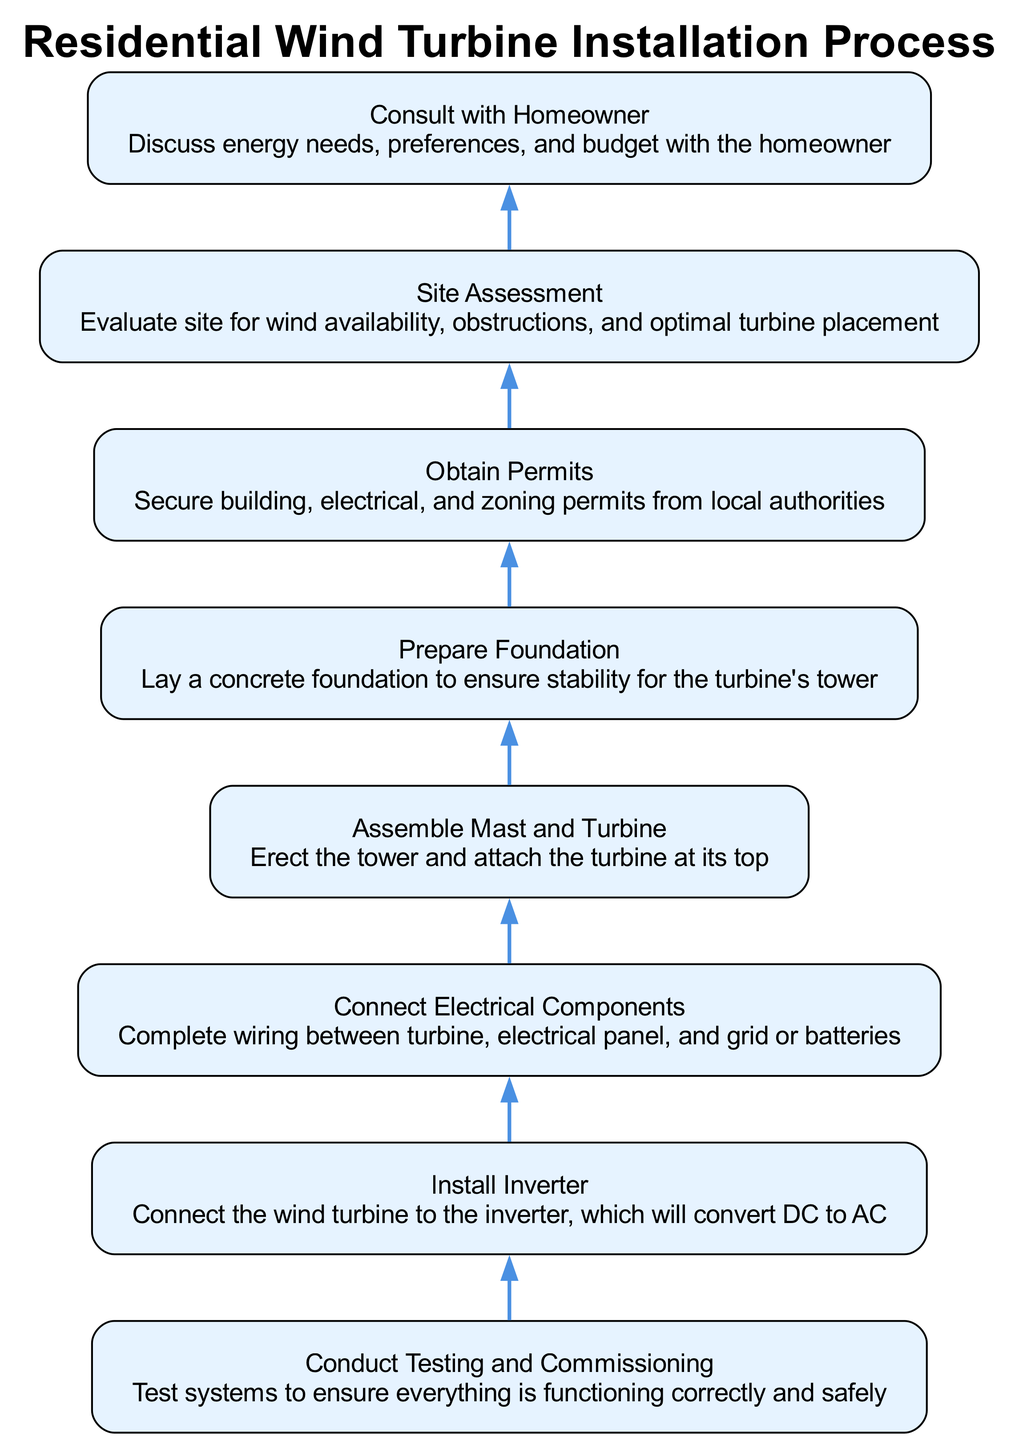What is the first step in the diagram? The first step, which is at the bottom of the flowchart, is "Consult with Homeowner". This is determined by starting from the bottom node and checking which step appears first.
Answer: Consult with Homeowner How many steps are in the installation process? By counting the nodes in the diagram, there are a total of eight distinct steps. Each step is represented by a node in the flowchart.
Answer: Eight What step immediately precedes "Conduct Testing and Commissioning"? The step that comes directly before "Conduct Testing and Commissioning" is "Install Inverter". This can be identified by tracing the flow from the bottom up and looking for the edge connecting to "Conduct Testing and Commissioning".
Answer: Install Inverter What is the purpose of the "Site Assessment" step? The purpose of the "Site Assessment" step is to evaluate site for wind availability, obstructions, and optimal turbine placement, as described in the details of that step in the diagram.
Answer: Evaluate site for wind availability Which step involves laying a concrete foundation? The step that involves laying a concrete foundation is "Prepare Foundation". This is explicitly mentioned in the details of that step when looking at the flowchart.
Answer: Prepare Foundation What is the last step in the flowchart? The last step in the flowchart is "Conduct Testing and Commissioning". This can be verified by checking the topmost node in the upward flow of the diagram, which represents the final action to be taken.
Answer: Conduct Testing and Commissioning What step must be completed before "Install Inverter"? The step that must be completed before "Install Inverter" is "Connect Electrical Components", since it is the direct predecessor step in the flowchart reflecting the installation process order.
Answer: Connect Electrical Components What information is discussed during the "Consult with Homeowner" step? During the "Consult with Homeowner" step, energy needs, preferences, and budget are discussed. This detail is provided in the description for that particular step in the diagram.
Answer: Energy needs, preferences, and budget 